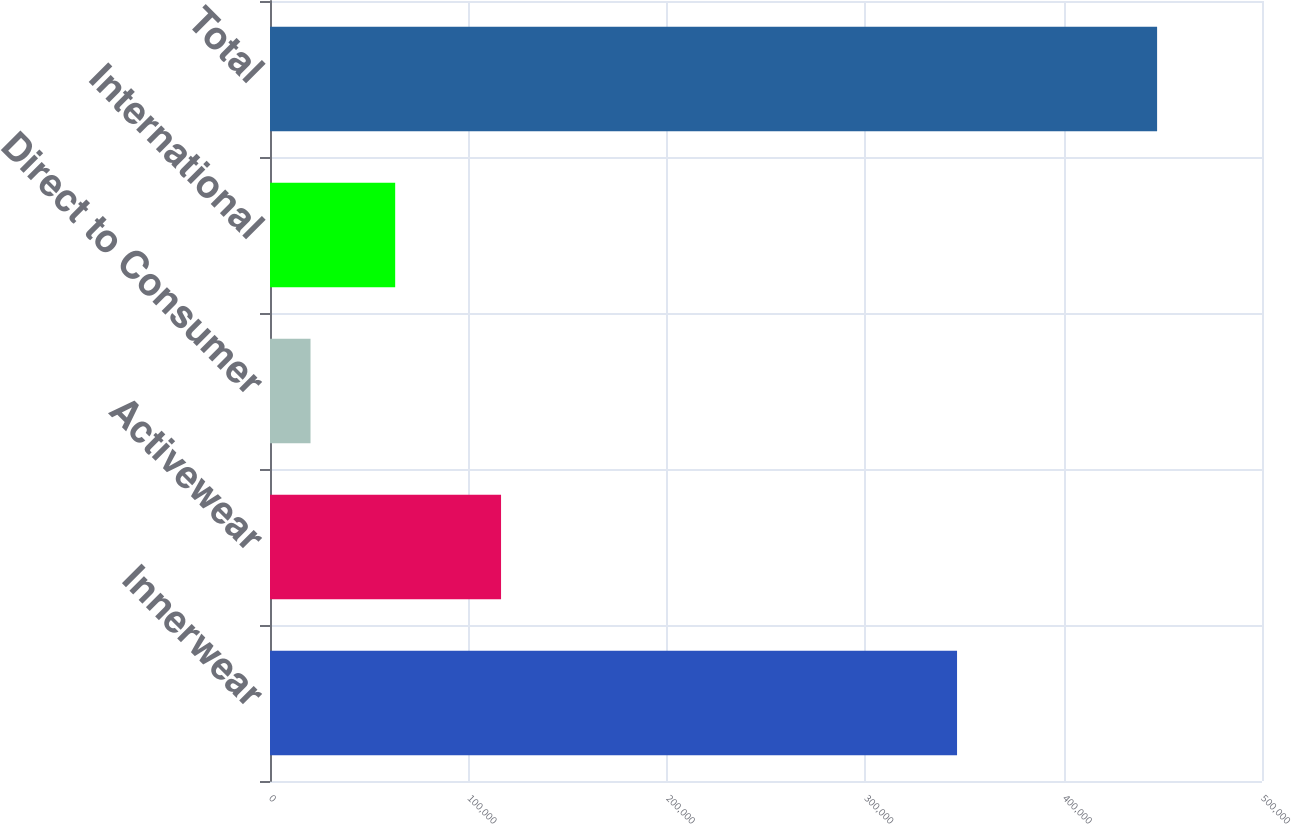Convert chart. <chart><loc_0><loc_0><loc_500><loc_500><bar_chart><fcel>Innerwear<fcel>Activewear<fcel>Direct to Consumer<fcel>International<fcel>Total<nl><fcel>346293<fcel>116457<fcel>20422<fcel>63092.5<fcel>447127<nl></chart> 